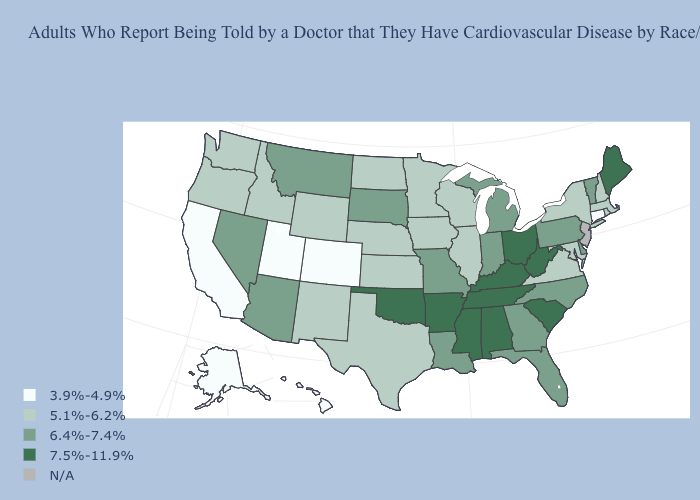Does the map have missing data?
Give a very brief answer. Yes. Name the states that have a value in the range 5.1%-6.2%?
Short answer required. Idaho, Illinois, Iowa, Kansas, Maryland, Massachusetts, Minnesota, Nebraska, New Hampshire, New Mexico, New York, North Dakota, Oregon, Rhode Island, Texas, Virginia, Washington, Wisconsin, Wyoming. Does the map have missing data?
Quick response, please. Yes. Which states have the highest value in the USA?
Write a very short answer. Alabama, Arkansas, Kentucky, Maine, Mississippi, Ohio, Oklahoma, South Carolina, Tennessee, West Virginia. Among the states that border Minnesota , which have the highest value?
Short answer required. South Dakota. Name the states that have a value in the range 5.1%-6.2%?
Quick response, please. Idaho, Illinois, Iowa, Kansas, Maryland, Massachusetts, Minnesota, Nebraska, New Hampshire, New Mexico, New York, North Dakota, Oregon, Rhode Island, Texas, Virginia, Washington, Wisconsin, Wyoming. What is the value of New York?
Give a very brief answer. 5.1%-6.2%. What is the value of North Carolina?
Keep it brief. 6.4%-7.4%. Among the states that border Oklahoma , which have the highest value?
Keep it brief. Arkansas. Name the states that have a value in the range 7.5%-11.9%?
Concise answer only. Alabama, Arkansas, Kentucky, Maine, Mississippi, Ohio, Oklahoma, South Carolina, Tennessee, West Virginia. Does Ohio have the highest value in the MidWest?
Write a very short answer. Yes. Among the states that border Tennessee , which have the highest value?
Write a very short answer. Alabama, Arkansas, Kentucky, Mississippi. 